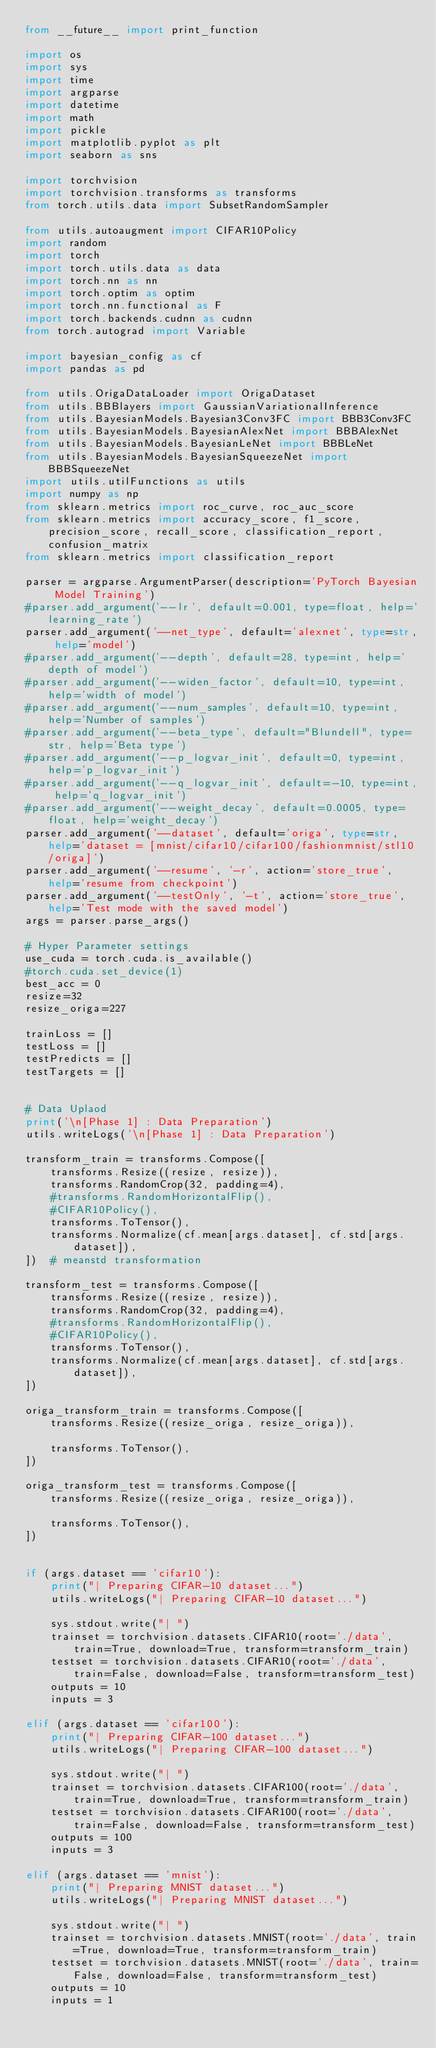Convert code to text. <code><loc_0><loc_0><loc_500><loc_500><_Python_>from __future__ import print_function

import os
import sys
import time
import argparse
import datetime
import math
import pickle
import matplotlib.pyplot as plt
import seaborn as sns

import torchvision
import torchvision.transforms as transforms
from torch.utils.data import SubsetRandomSampler

from utils.autoaugment import CIFAR10Policy
import random
import torch
import torch.utils.data as data
import torch.nn as nn
import torch.optim as optim
import torch.nn.functional as F
import torch.backends.cudnn as cudnn
from torch.autograd import Variable

import bayesian_config as cf
import pandas as pd

from utils.OrigaDataLoader import OrigaDataset
from utils.BBBlayers import GaussianVariationalInference
from utils.BayesianModels.Bayesian3Conv3FC import BBB3Conv3FC
from utils.BayesianModels.BayesianAlexNet import BBBAlexNet
from utils.BayesianModels.BayesianLeNet import BBBLeNet
from utils.BayesianModels.BayesianSqueezeNet import BBBSqueezeNet
import utils.utilFunctions as utils
import numpy as np
from sklearn.metrics import roc_curve, roc_auc_score
from sklearn.metrics import accuracy_score, f1_score, precision_score, recall_score, classification_report, confusion_matrix
from sklearn.metrics import classification_report

parser = argparse.ArgumentParser(description='PyTorch Bayesian Model Training')
#parser.add_argument('--lr', default=0.001, type=float, help='learning_rate')
parser.add_argument('--net_type', default='alexnet', type=str, help='model')
#parser.add_argument('--depth', default=28, type=int, help='depth of model')
#parser.add_argument('--widen_factor', default=10, type=int, help='width of model')
#parser.add_argument('--num_samples', default=10, type=int, help='Number of samples')
#parser.add_argument('--beta_type', default="Blundell", type=str, help='Beta type')
#parser.add_argument('--p_logvar_init', default=0, type=int, help='p_logvar_init')
#parser.add_argument('--q_logvar_init', default=-10, type=int, help='q_logvar_init')
#parser.add_argument('--weight_decay', default=0.0005, type=float, help='weight_decay')
parser.add_argument('--dataset', default='origa', type=str, help='dataset = [mnist/cifar10/cifar100/fashionmnist/stl10/origa]')
parser.add_argument('--resume', '-r', action='store_true', help='resume from checkpoint')
parser.add_argument('--testOnly', '-t', action='store_true', help='Test mode with the saved model')
args = parser.parse_args()

# Hyper Parameter settings
use_cuda = torch.cuda.is_available()
#torch.cuda.set_device(1)
best_acc = 0
resize=32
resize_origa=227

trainLoss = []
testLoss = []
testPredicts = []
testTargets = []


# Data Uplaod
print('\n[Phase 1] : Data Preparation')
utils.writeLogs('\n[Phase 1] : Data Preparation')

transform_train = transforms.Compose([
    transforms.Resize((resize, resize)),
    transforms.RandomCrop(32, padding=4),
    #transforms.RandomHorizontalFlip(),
    #CIFAR10Policy(),
    transforms.ToTensor(),
    transforms.Normalize(cf.mean[args.dataset], cf.std[args.dataset]),
])  # meanstd transformation

transform_test = transforms.Compose([
    transforms.Resize((resize, resize)),
    transforms.RandomCrop(32, padding=4),
    #transforms.RandomHorizontalFlip(),
    #CIFAR10Policy(),
    transforms.ToTensor(),
    transforms.Normalize(cf.mean[args.dataset], cf.std[args.dataset]),
])

origa_transform_train = transforms.Compose([
    transforms.Resize((resize_origa, resize_origa)),

    transforms.ToTensor(),
])

origa_transform_test = transforms.Compose([
    transforms.Resize((resize_origa, resize_origa)),

    transforms.ToTensor(),
])


if (args.dataset == 'cifar10'):
    print("| Preparing CIFAR-10 dataset...")
    utils.writeLogs("| Preparing CIFAR-10 dataset...")

    sys.stdout.write("| ")
    trainset = torchvision.datasets.CIFAR10(root='./data', train=True, download=True, transform=transform_train)
    testset = torchvision.datasets.CIFAR10(root='./data', train=False, download=False, transform=transform_test)
    outputs = 10
    inputs = 3

elif (args.dataset == 'cifar100'):
    print("| Preparing CIFAR-100 dataset...")
    utils.writeLogs("| Preparing CIFAR-100 dataset...")

    sys.stdout.write("| ")
    trainset = torchvision.datasets.CIFAR100(root='./data', train=True, download=True, transform=transform_train)
    testset = torchvision.datasets.CIFAR100(root='./data', train=False, download=False, transform=transform_test)
    outputs = 100
    inputs = 3

elif (args.dataset == 'mnist'):
    print("| Preparing MNIST dataset...")
    utils.writeLogs("| Preparing MNIST dataset...")

    sys.stdout.write("| ")
    trainset = torchvision.datasets.MNIST(root='./data', train=True, download=True, transform=transform_train)
    testset = torchvision.datasets.MNIST(root='./data', train=False, download=False, transform=transform_test)
    outputs = 10
    inputs = 1
</code> 